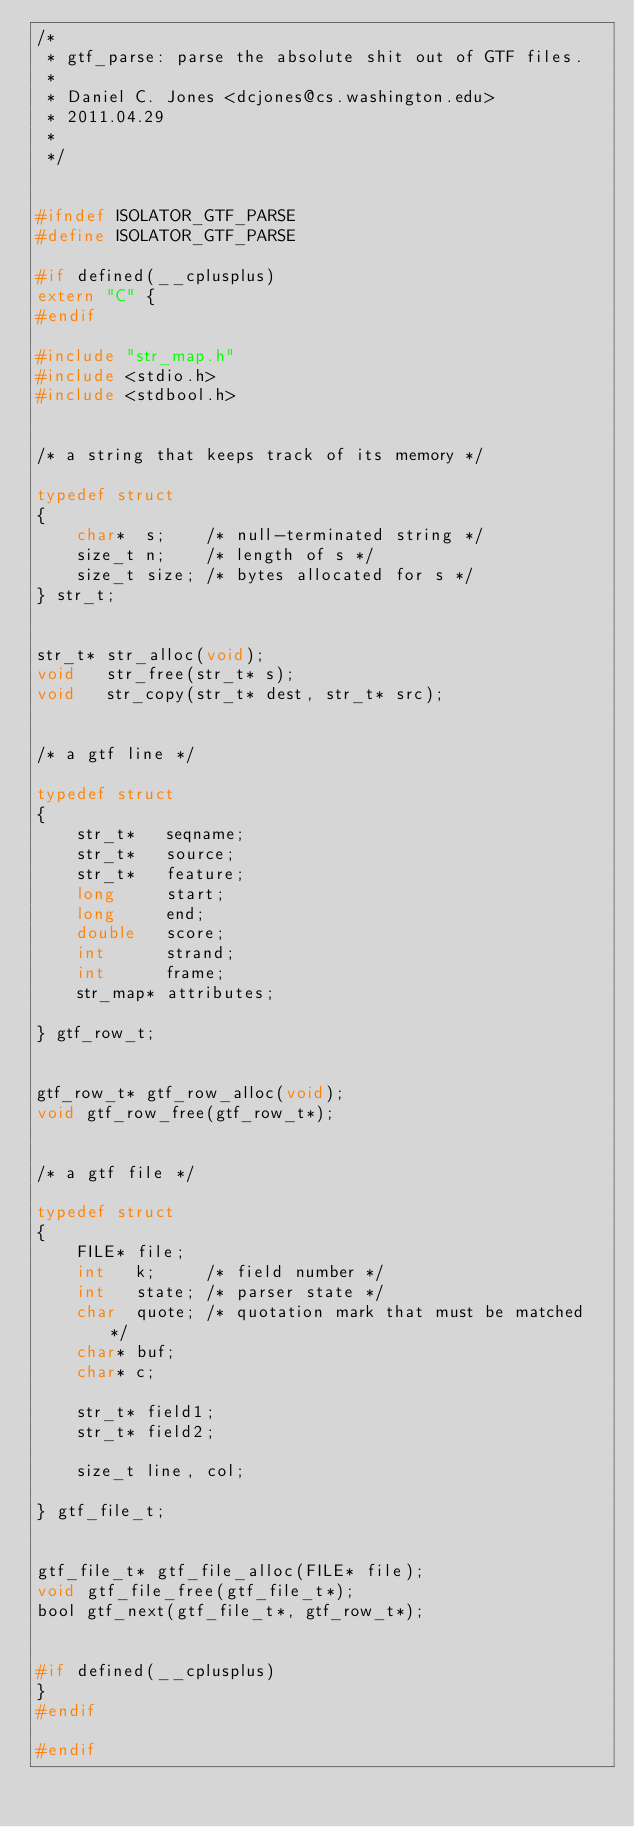Convert code to text. <code><loc_0><loc_0><loc_500><loc_500><_C_>/*
 * gtf_parse: parse the absolute shit out of GTF files.
 *
 * Daniel C. Jones <dcjones@cs.washington.edu>
 * 2011.04.29
 *
 */


#ifndef ISOLATOR_GTF_PARSE
#define ISOLATOR_GTF_PARSE

#if defined(__cplusplus)
extern "C" {
#endif

#include "str_map.h"
#include <stdio.h>
#include <stdbool.h>


/* a string that keeps track of its memory */

typedef struct
{
    char*  s;    /* null-terminated string */
    size_t n;    /* length of s */
    size_t size; /* bytes allocated for s */
} str_t;


str_t* str_alloc(void);
void   str_free(str_t* s);
void   str_copy(str_t* dest, str_t* src);


/* a gtf line */

typedef struct
{
    str_t*   seqname;
    str_t*   source;
    str_t*   feature;
    long     start;
    long     end;
    double   score;
    int      strand;
    int      frame;
    str_map* attributes;

} gtf_row_t;


gtf_row_t* gtf_row_alloc(void);
void gtf_row_free(gtf_row_t*);


/* a gtf file */

typedef struct
{
    FILE* file;
    int   k;     /* field number */
    int   state; /* parser state */
    char  quote; /* quotation mark that must be matched */
    char* buf;
    char* c;

    str_t* field1;
    str_t* field2;

    size_t line, col;

} gtf_file_t;


gtf_file_t* gtf_file_alloc(FILE* file);
void gtf_file_free(gtf_file_t*);
bool gtf_next(gtf_file_t*, gtf_row_t*);


#if defined(__cplusplus)
}
#endif

#endif



</code> 